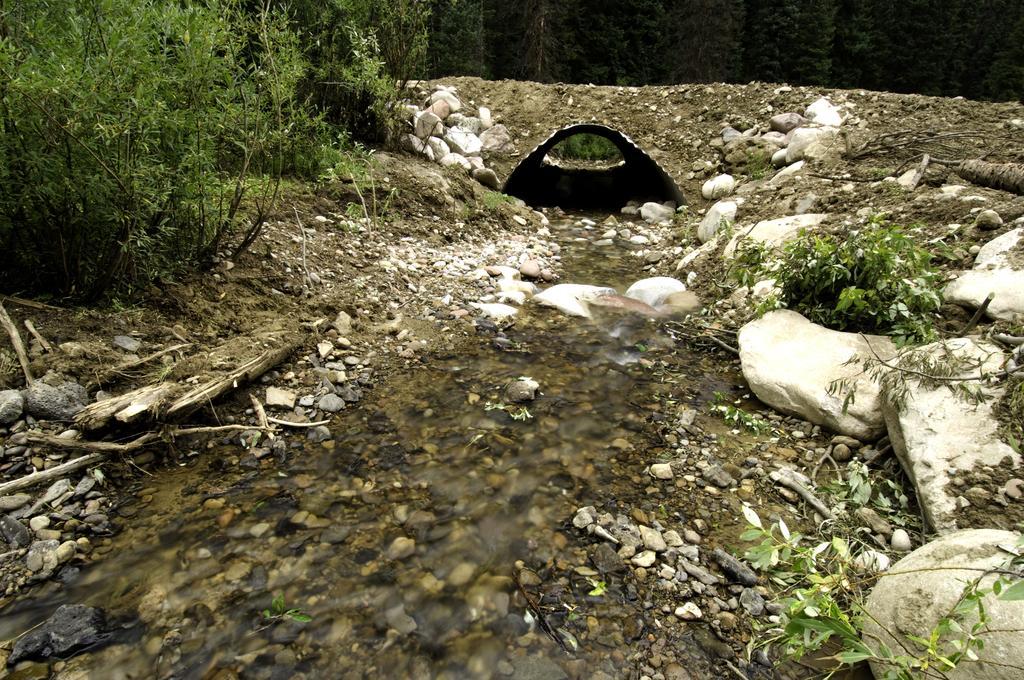How would you summarize this image in a sentence or two? In this picture, we can see water, stones, plants, trees and a small tunnel. 